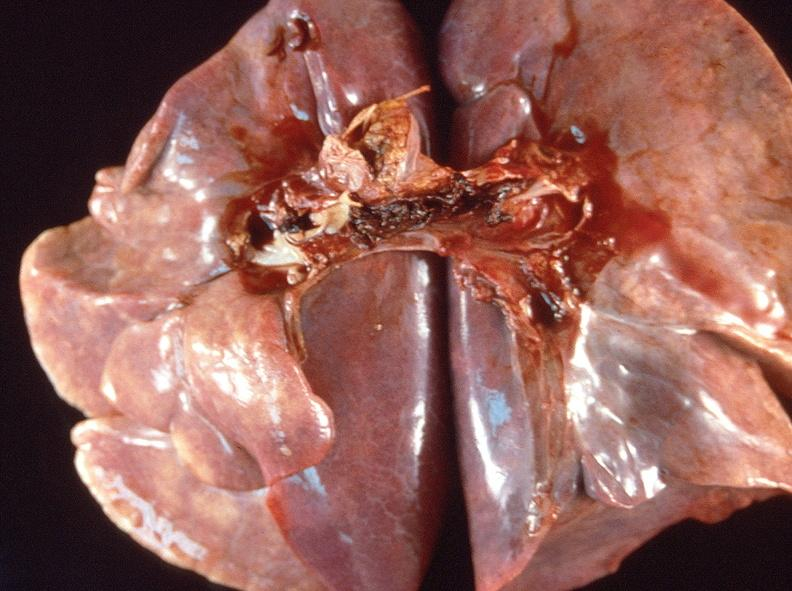what is present?
Answer the question using a single word or phrase. Respiratory 